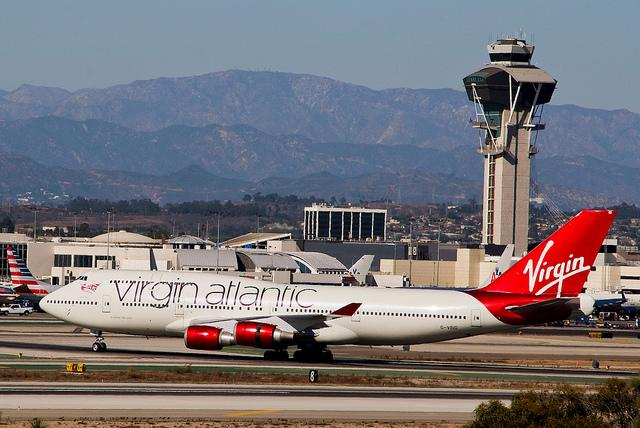What famous billionaire started the Virgin airline company?

Choices:
A) donald trump
B) sam walton
C) richard branson
D) michael bloomberg richard branson 